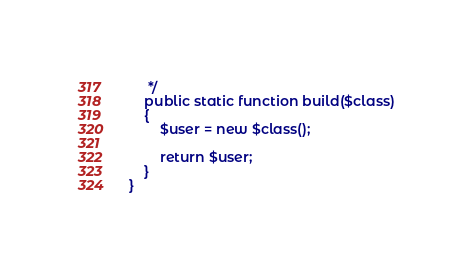<code> <loc_0><loc_0><loc_500><loc_500><_PHP_>     */
    public static function build($class)
    {
        $user = new $class();

        return $user;
    }
}
</code> 